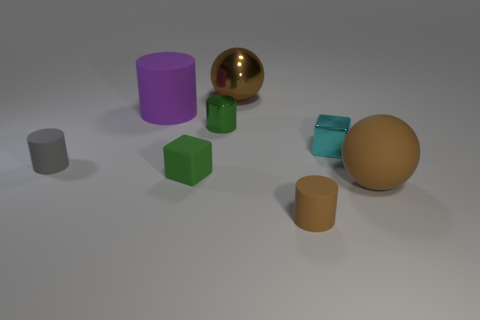Subtract all matte cylinders. How many cylinders are left? 1 Subtract all blocks. How many objects are left? 6 Subtract all brown cylinders. How many cylinders are left? 3 Add 2 tiny gray spheres. How many objects exist? 10 Subtract 3 cylinders. How many cylinders are left? 1 Subtract all gray cylinders. Subtract all cyan balls. How many cylinders are left? 3 Subtract all brown balls. How many green cylinders are left? 1 Subtract all blue rubber things. Subtract all purple matte cylinders. How many objects are left? 7 Add 2 small brown matte things. How many small brown matte things are left? 3 Add 6 small green cubes. How many small green cubes exist? 7 